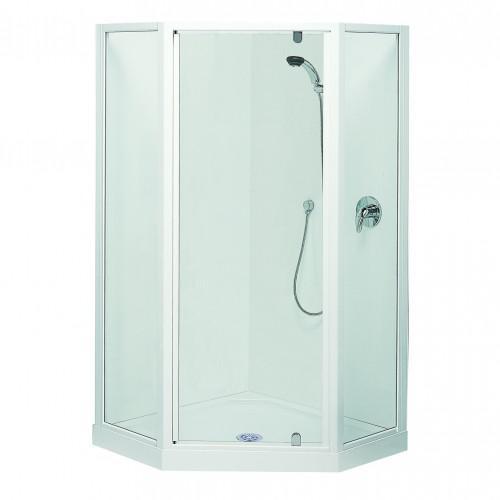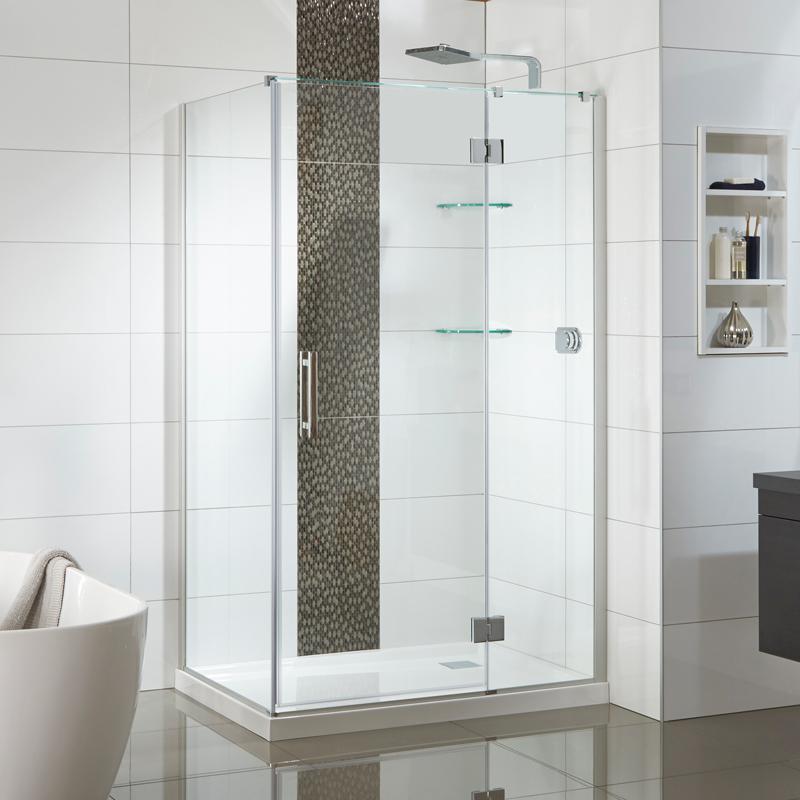The first image is the image on the left, the second image is the image on the right. Analyze the images presented: Is the assertion "The shower in the image on the left if against a solid color background." valid? Answer yes or no. Yes. 